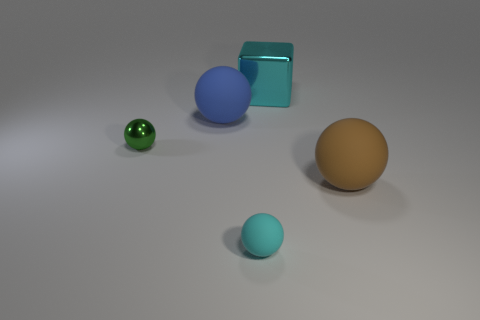Is the small sphere behind the brown matte ball made of the same material as the small thing that is in front of the brown thing?
Your answer should be very brief. No. What material is the small sphere behind the large matte sphere in front of the blue matte ball?
Your answer should be compact. Metal. There is a large thing in front of the green thing; what material is it?
Give a very brief answer. Rubber. How many small cyan things are the same shape as the small green metal object?
Ensure brevity in your answer.  1. Is the color of the cube the same as the small metallic sphere?
Offer a very short reply. No. There is a large ball that is behind the ball that is right of the small thing that is in front of the green metallic thing; what is its material?
Your answer should be very brief. Rubber. There is a large cyan cube; are there any cyan matte objects behind it?
Offer a terse response. No. What is the shape of the blue matte object that is the same size as the cyan cube?
Your response must be concise. Sphere. Does the large block have the same material as the small cyan thing?
Ensure brevity in your answer.  No. What number of metallic objects are brown things or large cyan objects?
Make the answer very short. 1. 